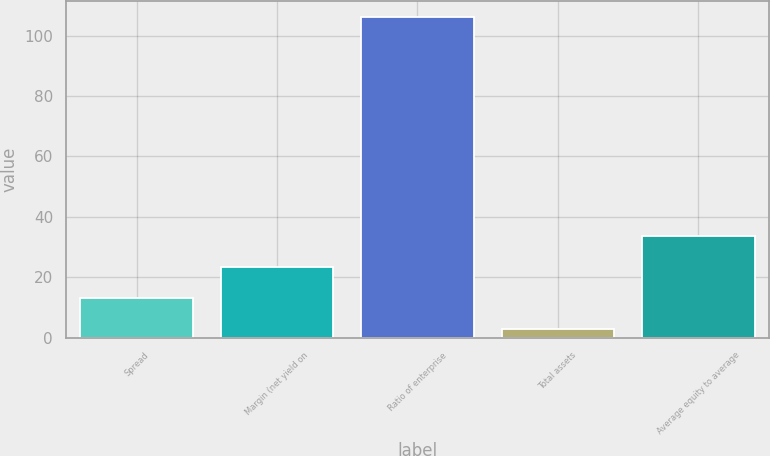Convert chart to OTSL. <chart><loc_0><loc_0><loc_500><loc_500><bar_chart><fcel>Spread<fcel>Margin (net yield on<fcel>Ratio of enterprise<fcel>Total assets<fcel>Average equity to average<nl><fcel>13.05<fcel>23.42<fcel>106.36<fcel>2.68<fcel>33.79<nl></chart> 